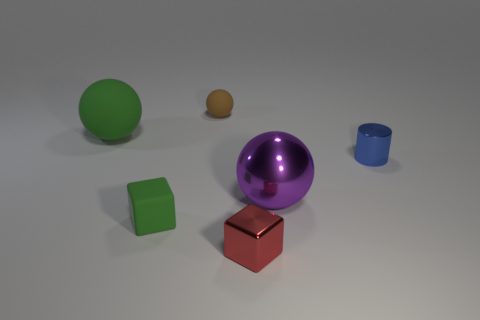Are there any other things that are the same shape as the tiny blue metallic thing?
Your answer should be compact. No. The big object behind the object to the right of the large sphere that is on the right side of the tiny green rubber object is what color?
Your answer should be very brief. Green. Are there fewer brown balls that are in front of the tiny blue metal thing than big things on the right side of the small brown thing?
Your answer should be compact. Yes. Is the small brown rubber object the same shape as the red metallic object?
Keep it short and to the point. No. What number of purple objects have the same size as the shiny cylinder?
Keep it short and to the point. 0. Is the number of small blue cylinders behind the small rubber sphere less than the number of rubber things?
Your response must be concise. Yes. What size is the green matte thing behind the green object that is in front of the cylinder?
Keep it short and to the point. Large. What number of objects are large cyan metal objects or small brown spheres?
Offer a terse response. 1. Are there any other rubber objects of the same color as the big matte thing?
Your response must be concise. Yes. Is the number of matte cubes less than the number of large brown shiny blocks?
Your answer should be compact. No. 